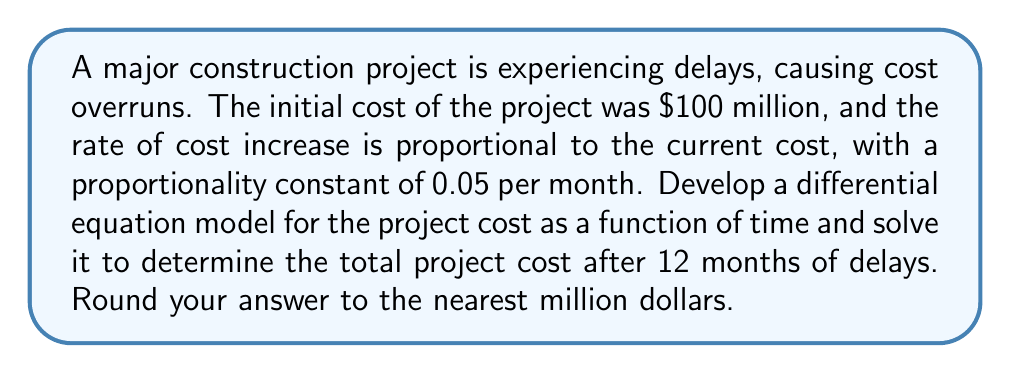Can you solve this math problem? Let's approach this problem step-by-step:

1) Let $C(t)$ be the cost of the project in millions of dollars at time $t$ in months.

2) Given information:
   - Initial cost: $C(0) = 100$ million dollars
   - Rate of cost increase is proportional to current cost
   - Proportionality constant: $k = 0.05$ per month

3) The differential equation model:
   
   $$\frac{dC}{dt} = 0.05C$$

   This equation states that the rate of change of cost with respect to time is proportional to the current cost.

4) This is a first-order linear differential equation. The general solution is:

   $$C(t) = Ae^{0.05t}$$

   where $A$ is a constant to be determined.

5) Use the initial condition to find $A$:
   
   $C(0) = 100 = Ae^{0.05(0)} = A$

   So, $A = 100$

6) The specific solution is:

   $$C(t) = 100e^{0.05t}$$

7) To find the cost after 12 months, evaluate $C(12)$:

   $$C(12) = 100e^{0.05(12)} = 100e^{0.6} \approx 182.21$$

8) Rounding to the nearest million:

   $C(12) \approx 182$ million dollars
Answer: $182 million 